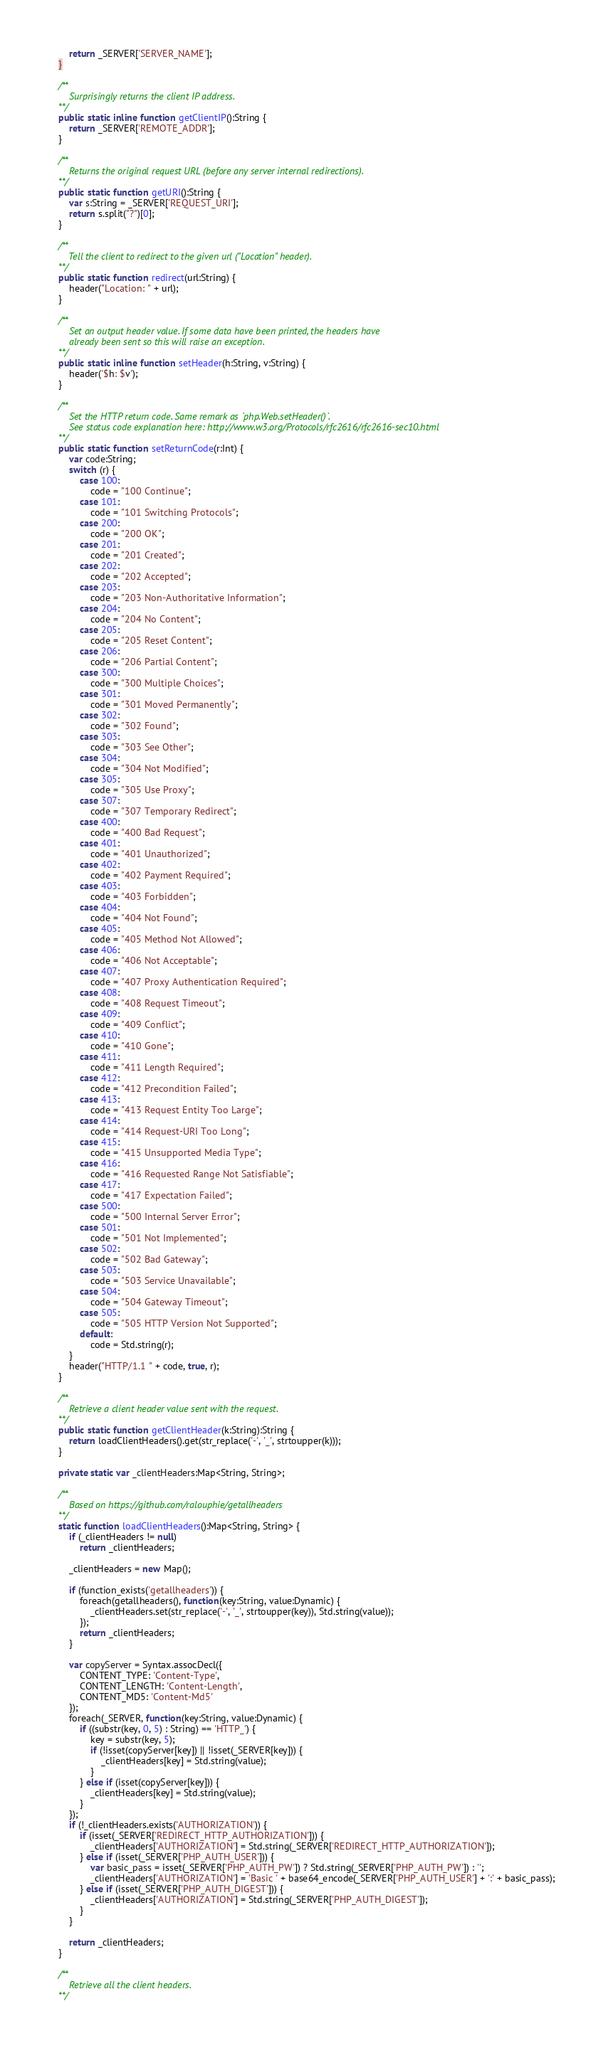Convert code to text. <code><loc_0><loc_0><loc_500><loc_500><_Haxe_>		return _SERVER['SERVER_NAME'];
	}

	/**
		Surprisingly returns the client IP address.
	**/
	public static inline function getClientIP():String {
		return _SERVER['REMOTE_ADDR'];
	}

	/**
		Returns the original request URL (before any server internal redirections).
	**/
	public static function getURI():String {
		var s:String = _SERVER['REQUEST_URI'];
		return s.split("?")[0];
	}

	/**
		Tell the client to redirect to the given url ("Location" header).
	**/
	public static function redirect(url:String) {
		header("Location: " + url);
	}

	/**
		Set an output header value. If some data have been printed, the headers have
		already been sent so this will raise an exception.
	**/
	public static inline function setHeader(h:String, v:String) {
		header('$h: $v');
	}

	/**
		Set the HTTP return code. Same remark as `php.Web.setHeader()`.
		See status code explanation here: http://www.w3.org/Protocols/rfc2616/rfc2616-sec10.html
	**/
	public static function setReturnCode(r:Int) {
		var code:String;
		switch (r) {
			case 100:
				code = "100 Continue";
			case 101:
				code = "101 Switching Protocols";
			case 200:
				code = "200 OK";
			case 201:
				code = "201 Created";
			case 202:
				code = "202 Accepted";
			case 203:
				code = "203 Non-Authoritative Information";
			case 204:
				code = "204 No Content";
			case 205:
				code = "205 Reset Content";
			case 206:
				code = "206 Partial Content";
			case 300:
				code = "300 Multiple Choices";
			case 301:
				code = "301 Moved Permanently";
			case 302:
				code = "302 Found";
			case 303:
				code = "303 See Other";
			case 304:
				code = "304 Not Modified";
			case 305:
				code = "305 Use Proxy";
			case 307:
				code = "307 Temporary Redirect";
			case 400:
				code = "400 Bad Request";
			case 401:
				code = "401 Unauthorized";
			case 402:
				code = "402 Payment Required";
			case 403:
				code = "403 Forbidden";
			case 404:
				code = "404 Not Found";
			case 405:
				code = "405 Method Not Allowed";
			case 406:
				code = "406 Not Acceptable";
			case 407:
				code = "407 Proxy Authentication Required";
			case 408:
				code = "408 Request Timeout";
			case 409:
				code = "409 Conflict";
			case 410:
				code = "410 Gone";
			case 411:
				code = "411 Length Required";
			case 412:
				code = "412 Precondition Failed";
			case 413:
				code = "413 Request Entity Too Large";
			case 414:
				code = "414 Request-URI Too Long";
			case 415:
				code = "415 Unsupported Media Type";
			case 416:
				code = "416 Requested Range Not Satisfiable";
			case 417:
				code = "417 Expectation Failed";
			case 500:
				code = "500 Internal Server Error";
			case 501:
				code = "501 Not Implemented";
			case 502:
				code = "502 Bad Gateway";
			case 503:
				code = "503 Service Unavailable";
			case 504:
				code = "504 Gateway Timeout";
			case 505:
				code = "505 HTTP Version Not Supported";
			default:
				code = Std.string(r);
		}
		header("HTTP/1.1 " + code, true, r);
	}

	/**
		Retrieve a client header value sent with the request.
	**/
	public static function getClientHeader(k:String):String {
		return loadClientHeaders().get(str_replace('-', '_', strtoupper(k)));
	}

	private static var _clientHeaders:Map<String, String>;

	/**
		Based on https://github.com/ralouphie/getallheaders
	**/
	static function loadClientHeaders():Map<String, String> {
		if (_clientHeaders != null)
			return _clientHeaders;

		_clientHeaders = new Map();

		if (function_exists('getallheaders')) {
			foreach(getallheaders(), function(key:String, value:Dynamic) {
				_clientHeaders.set(str_replace('-', '_', strtoupper(key)), Std.string(value));
			});
			return _clientHeaders;
		}

		var copyServer = Syntax.assocDecl({
			CONTENT_TYPE: 'Content-Type',
			CONTENT_LENGTH: 'Content-Length',
			CONTENT_MD5: 'Content-Md5'
		});
		foreach(_SERVER, function(key:String, value:Dynamic) {
			if ((substr(key, 0, 5) : String) == 'HTTP_') {
				key = substr(key, 5);
				if (!isset(copyServer[key]) || !isset(_SERVER[key])) {
					_clientHeaders[key] = Std.string(value);
				}
			} else if (isset(copyServer[key])) {
				_clientHeaders[key] = Std.string(value);
			}
		});
		if (!_clientHeaders.exists('AUTHORIZATION')) {
			if (isset(_SERVER['REDIRECT_HTTP_AUTHORIZATION'])) {
				_clientHeaders['AUTHORIZATION'] = Std.string(_SERVER['REDIRECT_HTTP_AUTHORIZATION']);
			} else if (isset(_SERVER['PHP_AUTH_USER'])) {
				var basic_pass = isset(_SERVER['PHP_AUTH_PW']) ? Std.string(_SERVER['PHP_AUTH_PW']) : '';
				_clientHeaders['AUTHORIZATION'] = 'Basic ' + base64_encode(_SERVER['PHP_AUTH_USER'] + ':' + basic_pass);
			} else if (isset(_SERVER['PHP_AUTH_DIGEST'])) {
				_clientHeaders['AUTHORIZATION'] = Std.string(_SERVER['PHP_AUTH_DIGEST']);
			}
		}

		return _clientHeaders;
	}

	/**
		Retrieve all the client headers.
	**/</code> 